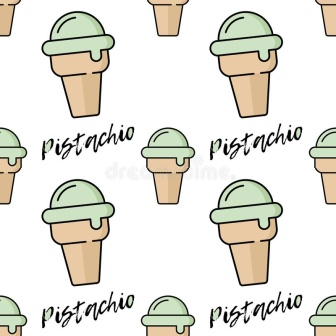Imagine you could enter this world. What would it feel like? Stepping into this world would be like entering a delightful dreamland where the air is sweet with the scent of pistachio ice cream. The sight of perfectly arranged rows of ice cream cones stretching out in all directions would be mesmerizing. Each cone would possess a whimsical touch, exuding an inviting aura that makes you yearn to reach out and indulge in the creamy goodness. The vibrant green of the ice cream and the stylishly written text might create a sense of fun and playfulness, evoking a carefree, joyful experience. 